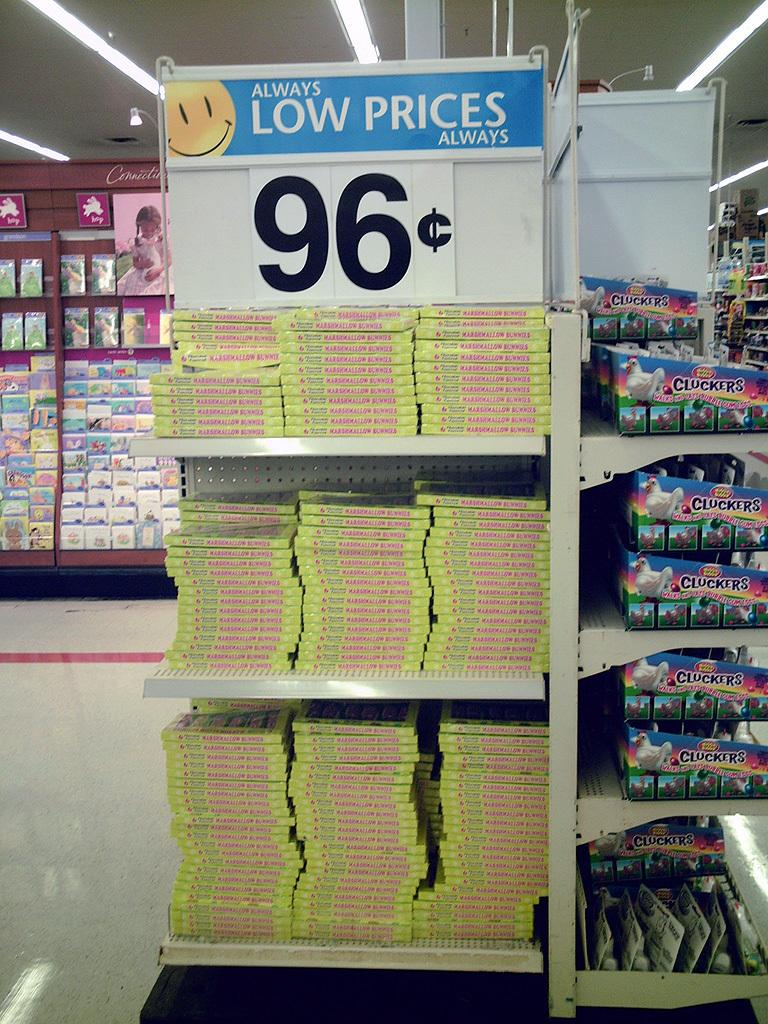Provide a one-sentence caption for the provided image. a shel in Walmart displaying for 96 cents. 